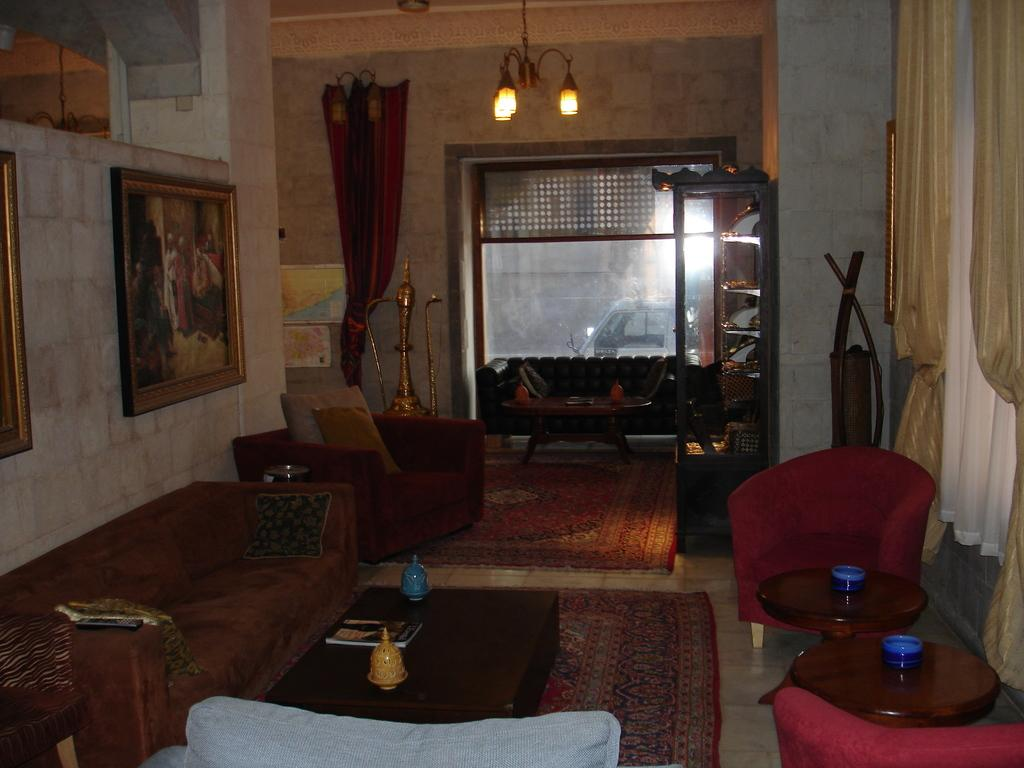What is the color of the wall in the image? The wall in the image is white. What can be seen hanging on the wall? There is a photo frame in the image. What type of window treatment is present in the image? There is a curtain in the image. What type of lighting is visible in the image? There are lights in the image. How many windows are present in the image? There are windows in the image. What type of furniture is present in the image? There are sofas and a table in the image. Can you tell me how many cubs are playing on the sofas in the image? There are no cubs present in the image; it features a white wall, a photo frame, a curtain, lights, windows, sofas, and a table. What type of business is being conducted in the image? There is no indication of a business being conducted in the image. 